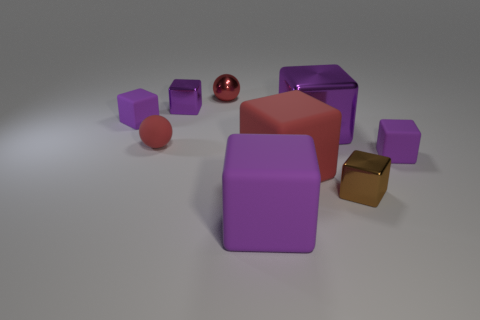Subtract all red cylinders. How many purple cubes are left? 5 Subtract all brown blocks. How many blocks are left? 6 Subtract all big metal blocks. How many blocks are left? 6 Subtract all gray cubes. Subtract all brown cylinders. How many cubes are left? 7 Add 1 purple cubes. How many objects exist? 10 Subtract all blocks. How many objects are left? 2 Subtract 0 cyan balls. How many objects are left? 9 Subtract all green metallic objects. Subtract all blocks. How many objects are left? 2 Add 8 large purple cubes. How many large purple cubes are left? 10 Add 6 small shiny cylinders. How many small shiny cylinders exist? 6 